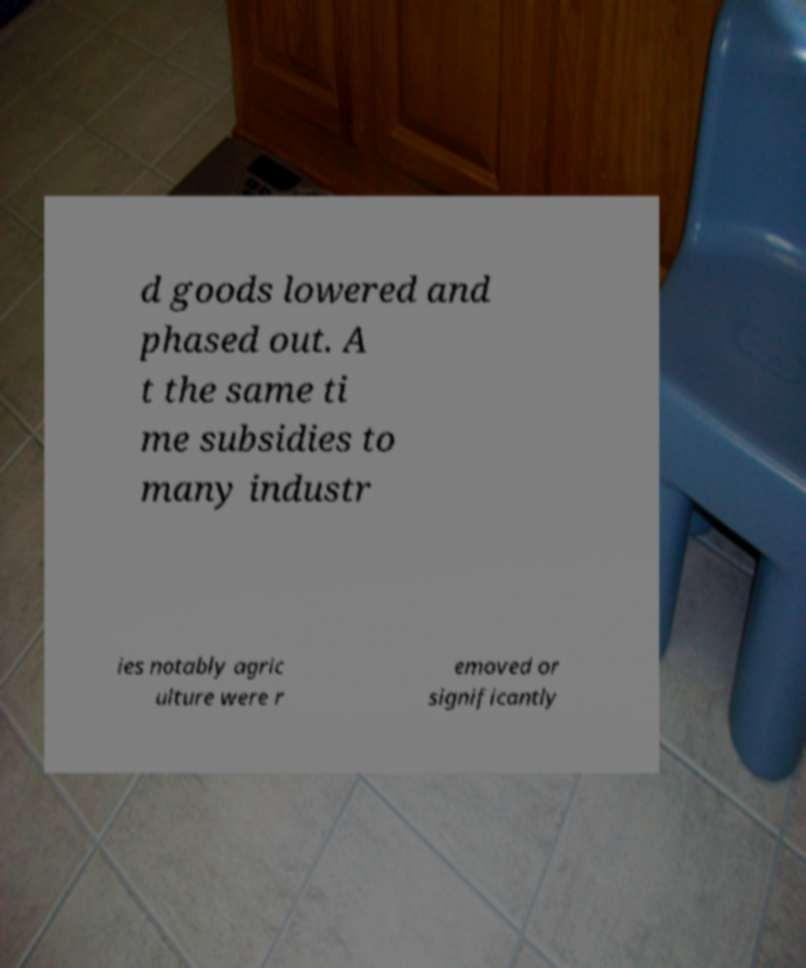Please identify and transcribe the text found in this image. d goods lowered and phased out. A t the same ti me subsidies to many industr ies notably agric ulture were r emoved or significantly 